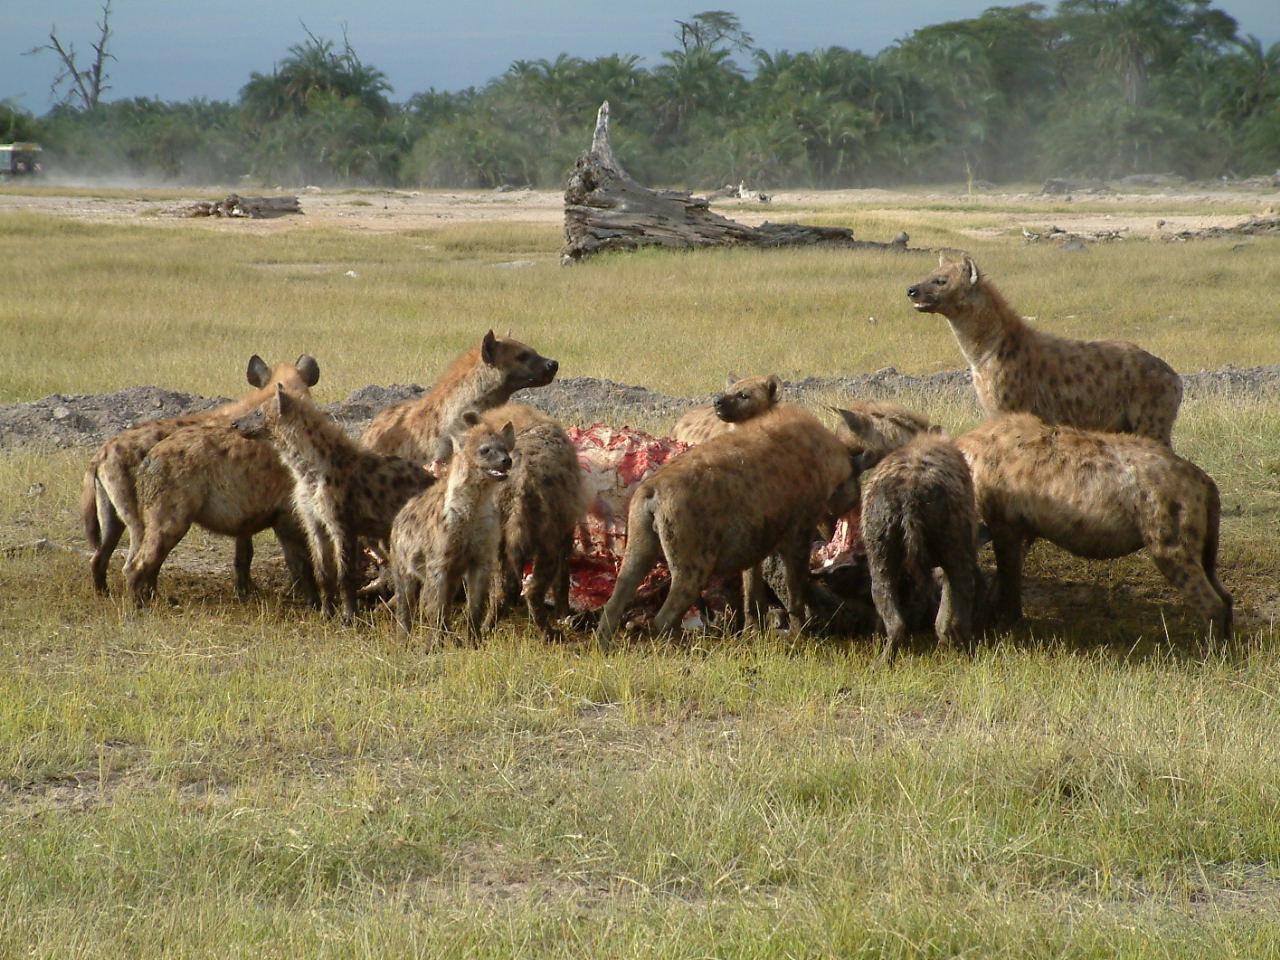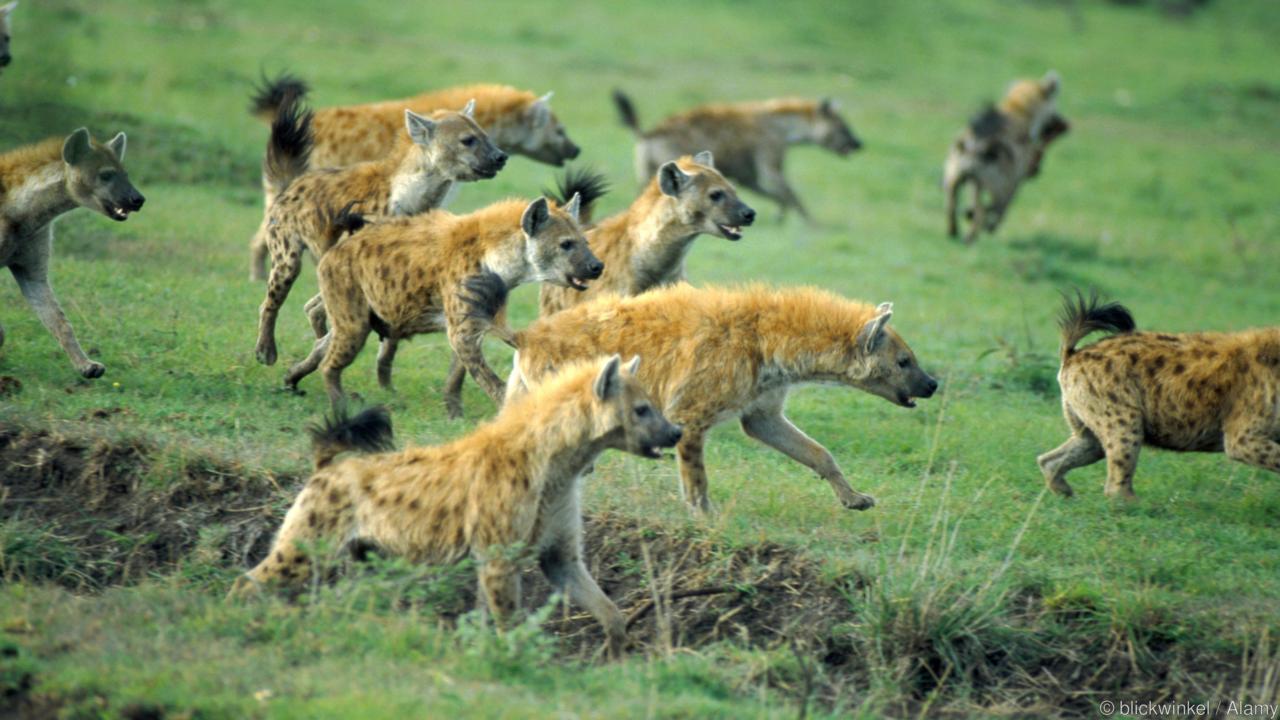The first image is the image on the left, the second image is the image on the right. Examine the images to the left and right. Is the description "Some of the animals are eating their prey." accurate? Answer yes or no. Yes. The first image is the image on the left, the second image is the image on the right. For the images displayed, is the sentence "At least one of the images shows hyenas eating a carcass." factually correct? Answer yes or no. Yes. 